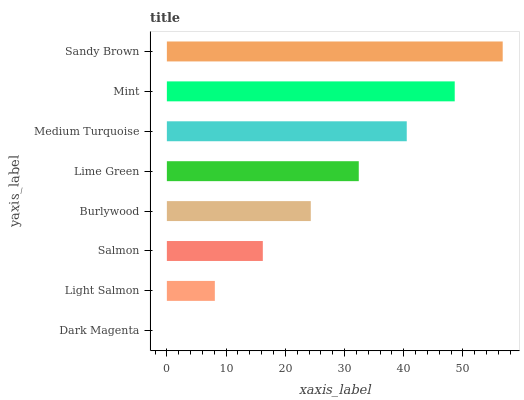Is Dark Magenta the minimum?
Answer yes or no. Yes. Is Sandy Brown the maximum?
Answer yes or no. Yes. Is Light Salmon the minimum?
Answer yes or no. No. Is Light Salmon the maximum?
Answer yes or no. No. Is Light Salmon greater than Dark Magenta?
Answer yes or no. Yes. Is Dark Magenta less than Light Salmon?
Answer yes or no. Yes. Is Dark Magenta greater than Light Salmon?
Answer yes or no. No. Is Light Salmon less than Dark Magenta?
Answer yes or no. No. Is Lime Green the high median?
Answer yes or no. Yes. Is Burlywood the low median?
Answer yes or no. Yes. Is Burlywood the high median?
Answer yes or no. No. Is Light Salmon the low median?
Answer yes or no. No. 